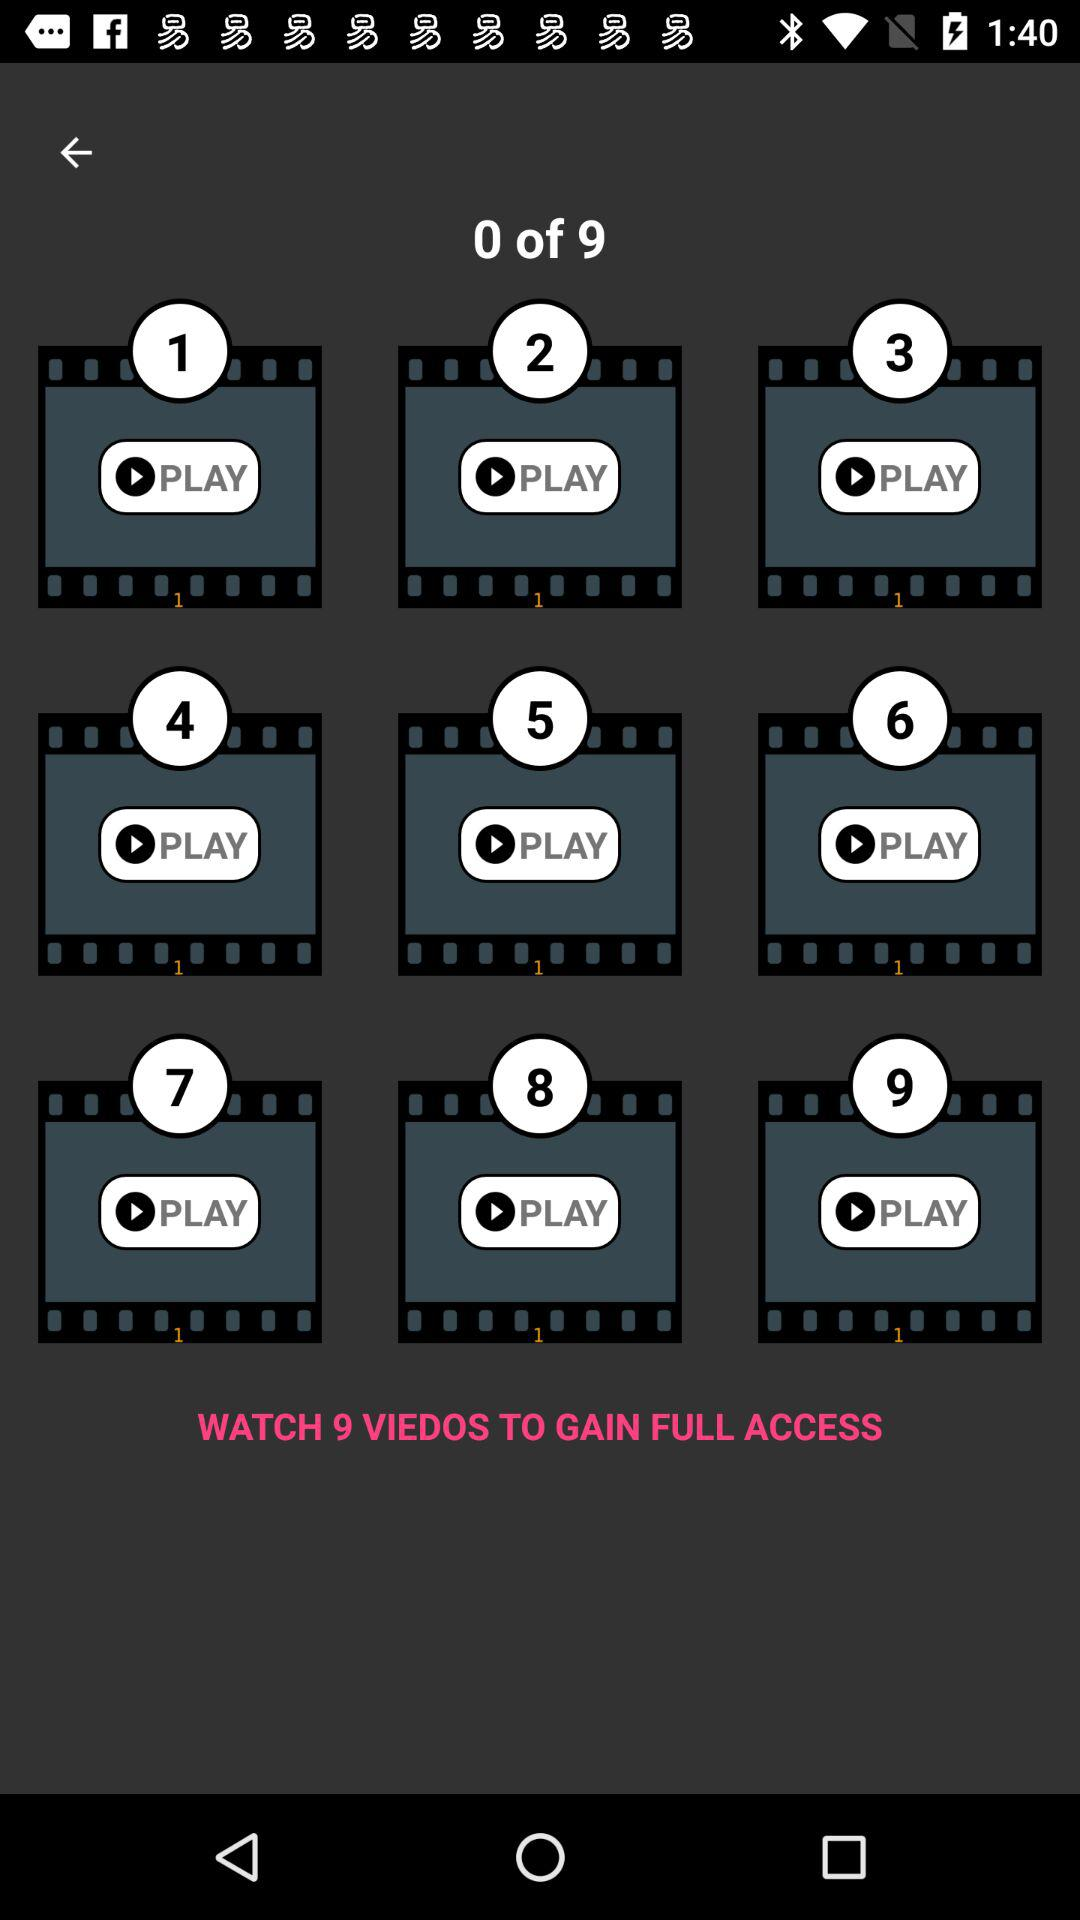How many videos are there in total?
Answer the question using a single word or phrase. 9 